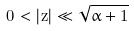<formula> <loc_0><loc_0><loc_500><loc_500>0 < | z | \ll \sqrt { \alpha + 1 }</formula> 